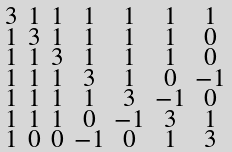<formula> <loc_0><loc_0><loc_500><loc_500>\begin{smallmatrix} 3 & 1 & 1 & 1 & 1 & 1 & 1 \\ 1 & 3 & 1 & 1 & 1 & 1 & 0 \\ 1 & 1 & 3 & 1 & 1 & 1 & 0 \\ 1 & 1 & 1 & 3 & 1 & 0 & - 1 \\ 1 & 1 & 1 & 1 & 3 & - 1 & 0 \\ 1 & 1 & 1 & 0 & - 1 & 3 & 1 \\ 1 & 0 & 0 & - 1 & 0 & 1 & 3 \end{smallmatrix}</formula> 